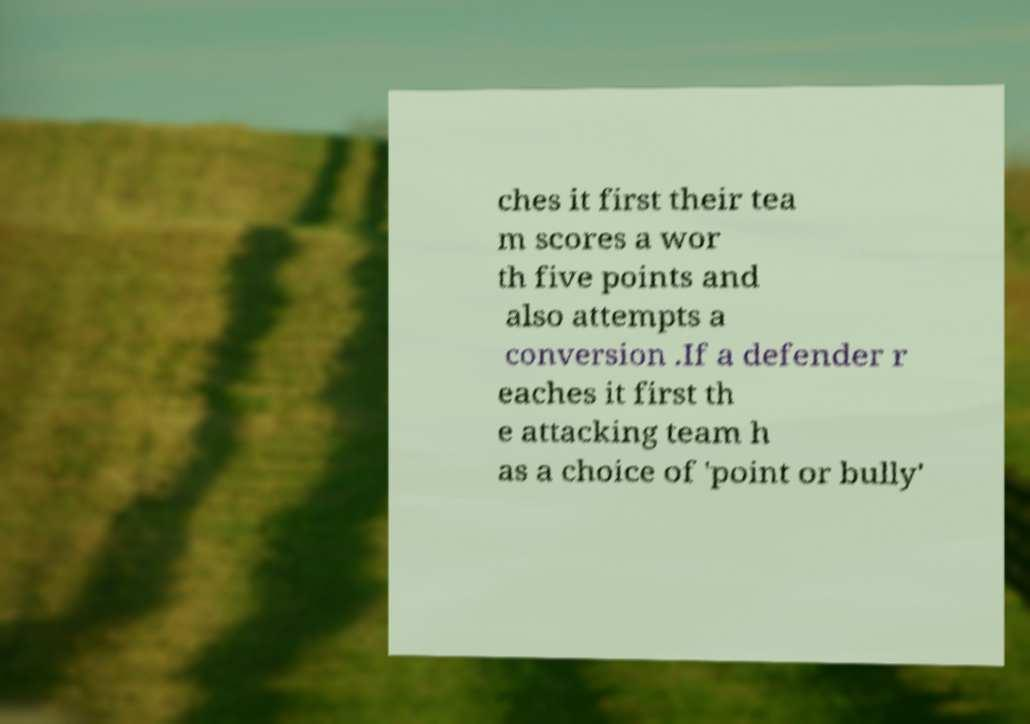Can you read and provide the text displayed in the image?This photo seems to have some interesting text. Can you extract and type it out for me? ches it first their tea m scores a wor th five points and also attempts a conversion .If a defender r eaches it first th e attacking team h as a choice of 'point or bully' 